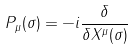<formula> <loc_0><loc_0><loc_500><loc_500>P _ { \mu } ( \sigma ) = - i \frac { \delta } { \delta X ^ { \mu } ( \sigma ) }</formula> 